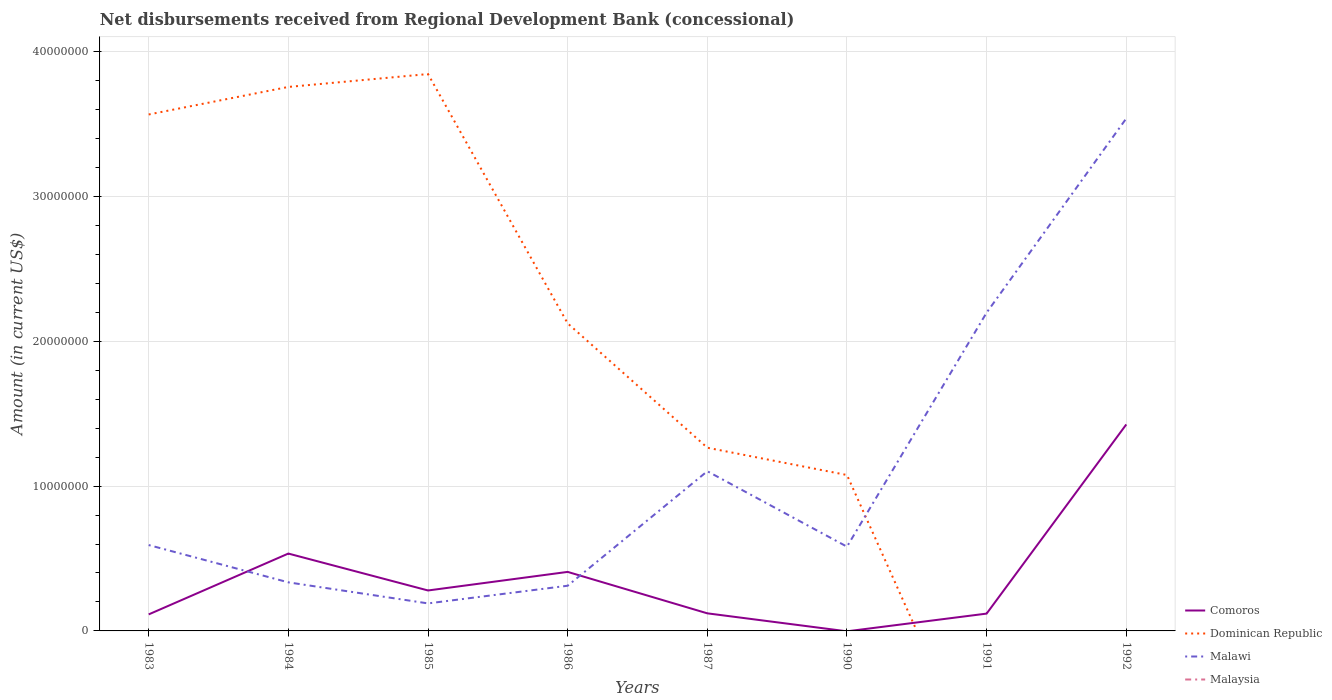How many different coloured lines are there?
Make the answer very short. 3. What is the total amount of disbursements received from Regional Development Bank in Comoros in the graph?
Offer a very short reply. 1.80e+04. What is the difference between the highest and the second highest amount of disbursements received from Regional Development Bank in Comoros?
Your answer should be very brief. 1.43e+07. How many years are there in the graph?
Offer a very short reply. 8. Does the graph contain any zero values?
Your response must be concise. Yes. Where does the legend appear in the graph?
Provide a succinct answer. Bottom right. How many legend labels are there?
Your answer should be compact. 4. What is the title of the graph?
Your answer should be very brief. Net disbursements received from Regional Development Bank (concessional). What is the label or title of the X-axis?
Your answer should be very brief. Years. What is the Amount (in current US$) in Comoros in 1983?
Provide a short and direct response. 1.14e+06. What is the Amount (in current US$) in Dominican Republic in 1983?
Ensure brevity in your answer.  3.57e+07. What is the Amount (in current US$) of Malawi in 1983?
Ensure brevity in your answer.  5.93e+06. What is the Amount (in current US$) of Malaysia in 1983?
Ensure brevity in your answer.  0. What is the Amount (in current US$) in Comoros in 1984?
Your answer should be compact. 5.34e+06. What is the Amount (in current US$) of Dominican Republic in 1984?
Your answer should be compact. 3.76e+07. What is the Amount (in current US$) in Malawi in 1984?
Make the answer very short. 3.35e+06. What is the Amount (in current US$) of Malaysia in 1984?
Offer a terse response. 0. What is the Amount (in current US$) in Comoros in 1985?
Make the answer very short. 2.79e+06. What is the Amount (in current US$) of Dominican Republic in 1985?
Your answer should be compact. 3.85e+07. What is the Amount (in current US$) in Malawi in 1985?
Your response must be concise. 1.90e+06. What is the Amount (in current US$) in Malaysia in 1985?
Ensure brevity in your answer.  0. What is the Amount (in current US$) in Comoros in 1986?
Your answer should be compact. 4.08e+06. What is the Amount (in current US$) in Dominican Republic in 1986?
Your answer should be compact. 2.12e+07. What is the Amount (in current US$) of Malawi in 1986?
Keep it short and to the point. 3.12e+06. What is the Amount (in current US$) in Comoros in 1987?
Keep it short and to the point. 1.21e+06. What is the Amount (in current US$) of Dominican Republic in 1987?
Provide a short and direct response. 1.26e+07. What is the Amount (in current US$) of Malawi in 1987?
Give a very brief answer. 1.10e+07. What is the Amount (in current US$) in Comoros in 1990?
Offer a terse response. 0. What is the Amount (in current US$) in Dominican Republic in 1990?
Keep it short and to the point. 1.08e+07. What is the Amount (in current US$) in Malawi in 1990?
Offer a terse response. 5.82e+06. What is the Amount (in current US$) in Malaysia in 1990?
Provide a short and direct response. 0. What is the Amount (in current US$) in Comoros in 1991?
Offer a very short reply. 1.20e+06. What is the Amount (in current US$) of Malawi in 1991?
Your answer should be compact. 2.20e+07. What is the Amount (in current US$) of Comoros in 1992?
Keep it short and to the point. 1.43e+07. What is the Amount (in current US$) of Dominican Republic in 1992?
Provide a succinct answer. 0. What is the Amount (in current US$) of Malawi in 1992?
Your answer should be very brief. 3.54e+07. Across all years, what is the maximum Amount (in current US$) in Comoros?
Provide a short and direct response. 1.43e+07. Across all years, what is the maximum Amount (in current US$) in Dominican Republic?
Offer a terse response. 3.85e+07. Across all years, what is the maximum Amount (in current US$) of Malawi?
Keep it short and to the point. 3.54e+07. Across all years, what is the minimum Amount (in current US$) of Malawi?
Keep it short and to the point. 1.90e+06. What is the total Amount (in current US$) in Comoros in the graph?
Provide a short and direct response. 3.00e+07. What is the total Amount (in current US$) in Dominican Republic in the graph?
Offer a terse response. 1.56e+08. What is the total Amount (in current US$) of Malawi in the graph?
Offer a very short reply. 8.85e+07. What is the difference between the Amount (in current US$) in Comoros in 1983 and that in 1984?
Your response must be concise. -4.20e+06. What is the difference between the Amount (in current US$) in Dominican Republic in 1983 and that in 1984?
Ensure brevity in your answer.  -1.90e+06. What is the difference between the Amount (in current US$) in Malawi in 1983 and that in 1984?
Make the answer very short. 2.58e+06. What is the difference between the Amount (in current US$) of Comoros in 1983 and that in 1985?
Your response must be concise. -1.65e+06. What is the difference between the Amount (in current US$) in Dominican Republic in 1983 and that in 1985?
Give a very brief answer. -2.79e+06. What is the difference between the Amount (in current US$) of Malawi in 1983 and that in 1985?
Give a very brief answer. 4.03e+06. What is the difference between the Amount (in current US$) of Comoros in 1983 and that in 1986?
Give a very brief answer. -2.94e+06. What is the difference between the Amount (in current US$) of Dominican Republic in 1983 and that in 1986?
Give a very brief answer. 1.44e+07. What is the difference between the Amount (in current US$) in Malawi in 1983 and that in 1986?
Provide a short and direct response. 2.81e+06. What is the difference between the Amount (in current US$) of Comoros in 1983 and that in 1987?
Give a very brief answer. -7.30e+04. What is the difference between the Amount (in current US$) of Dominican Republic in 1983 and that in 1987?
Make the answer very short. 2.30e+07. What is the difference between the Amount (in current US$) of Malawi in 1983 and that in 1987?
Ensure brevity in your answer.  -5.10e+06. What is the difference between the Amount (in current US$) in Dominican Republic in 1983 and that in 1990?
Your response must be concise. 2.49e+07. What is the difference between the Amount (in current US$) in Malawi in 1983 and that in 1990?
Give a very brief answer. 1.12e+05. What is the difference between the Amount (in current US$) in Comoros in 1983 and that in 1991?
Give a very brief answer. -5.50e+04. What is the difference between the Amount (in current US$) of Malawi in 1983 and that in 1991?
Keep it short and to the point. -1.60e+07. What is the difference between the Amount (in current US$) of Comoros in 1983 and that in 1992?
Provide a short and direct response. -1.31e+07. What is the difference between the Amount (in current US$) in Malawi in 1983 and that in 1992?
Offer a terse response. -2.95e+07. What is the difference between the Amount (in current US$) in Comoros in 1984 and that in 1985?
Provide a succinct answer. 2.55e+06. What is the difference between the Amount (in current US$) in Dominican Republic in 1984 and that in 1985?
Offer a very short reply. -8.89e+05. What is the difference between the Amount (in current US$) of Malawi in 1984 and that in 1985?
Offer a terse response. 1.45e+06. What is the difference between the Amount (in current US$) in Comoros in 1984 and that in 1986?
Offer a very short reply. 1.27e+06. What is the difference between the Amount (in current US$) of Dominican Republic in 1984 and that in 1986?
Provide a succinct answer. 1.63e+07. What is the difference between the Amount (in current US$) in Malawi in 1984 and that in 1986?
Your response must be concise. 2.34e+05. What is the difference between the Amount (in current US$) in Comoros in 1984 and that in 1987?
Your answer should be compact. 4.13e+06. What is the difference between the Amount (in current US$) in Dominican Republic in 1984 and that in 1987?
Provide a short and direct response. 2.49e+07. What is the difference between the Amount (in current US$) in Malawi in 1984 and that in 1987?
Your answer should be very brief. -7.67e+06. What is the difference between the Amount (in current US$) in Dominican Republic in 1984 and that in 1990?
Provide a succinct answer. 2.68e+07. What is the difference between the Amount (in current US$) in Malawi in 1984 and that in 1990?
Your response must be concise. -2.46e+06. What is the difference between the Amount (in current US$) in Comoros in 1984 and that in 1991?
Ensure brevity in your answer.  4.15e+06. What is the difference between the Amount (in current US$) of Malawi in 1984 and that in 1991?
Offer a very short reply. -1.86e+07. What is the difference between the Amount (in current US$) in Comoros in 1984 and that in 1992?
Your response must be concise. -8.92e+06. What is the difference between the Amount (in current US$) of Malawi in 1984 and that in 1992?
Offer a terse response. -3.20e+07. What is the difference between the Amount (in current US$) in Comoros in 1985 and that in 1986?
Give a very brief answer. -1.28e+06. What is the difference between the Amount (in current US$) of Dominican Republic in 1985 and that in 1986?
Keep it short and to the point. 1.72e+07. What is the difference between the Amount (in current US$) of Malawi in 1985 and that in 1986?
Offer a very short reply. -1.22e+06. What is the difference between the Amount (in current US$) in Comoros in 1985 and that in 1987?
Offer a very short reply. 1.58e+06. What is the difference between the Amount (in current US$) of Dominican Republic in 1985 and that in 1987?
Keep it short and to the point. 2.58e+07. What is the difference between the Amount (in current US$) in Malawi in 1985 and that in 1987?
Offer a terse response. -9.13e+06. What is the difference between the Amount (in current US$) in Dominican Republic in 1985 and that in 1990?
Ensure brevity in your answer.  2.77e+07. What is the difference between the Amount (in current US$) of Malawi in 1985 and that in 1990?
Your answer should be compact. -3.92e+06. What is the difference between the Amount (in current US$) of Comoros in 1985 and that in 1991?
Ensure brevity in your answer.  1.60e+06. What is the difference between the Amount (in current US$) of Malawi in 1985 and that in 1991?
Ensure brevity in your answer.  -2.01e+07. What is the difference between the Amount (in current US$) of Comoros in 1985 and that in 1992?
Your response must be concise. -1.15e+07. What is the difference between the Amount (in current US$) in Malawi in 1985 and that in 1992?
Provide a short and direct response. -3.35e+07. What is the difference between the Amount (in current US$) in Comoros in 1986 and that in 1987?
Ensure brevity in your answer.  2.86e+06. What is the difference between the Amount (in current US$) of Dominican Republic in 1986 and that in 1987?
Your response must be concise. 8.59e+06. What is the difference between the Amount (in current US$) of Malawi in 1986 and that in 1987?
Give a very brief answer. -7.91e+06. What is the difference between the Amount (in current US$) of Dominican Republic in 1986 and that in 1990?
Make the answer very short. 1.05e+07. What is the difference between the Amount (in current US$) in Malawi in 1986 and that in 1990?
Your response must be concise. -2.70e+06. What is the difference between the Amount (in current US$) in Comoros in 1986 and that in 1991?
Provide a short and direct response. 2.88e+06. What is the difference between the Amount (in current US$) of Malawi in 1986 and that in 1991?
Offer a very short reply. -1.89e+07. What is the difference between the Amount (in current US$) in Comoros in 1986 and that in 1992?
Give a very brief answer. -1.02e+07. What is the difference between the Amount (in current US$) of Malawi in 1986 and that in 1992?
Offer a very short reply. -3.23e+07. What is the difference between the Amount (in current US$) of Dominican Republic in 1987 and that in 1990?
Offer a very short reply. 1.88e+06. What is the difference between the Amount (in current US$) of Malawi in 1987 and that in 1990?
Provide a short and direct response. 5.21e+06. What is the difference between the Amount (in current US$) of Comoros in 1987 and that in 1991?
Offer a terse response. 1.80e+04. What is the difference between the Amount (in current US$) in Malawi in 1987 and that in 1991?
Offer a very short reply. -1.10e+07. What is the difference between the Amount (in current US$) of Comoros in 1987 and that in 1992?
Your answer should be compact. -1.30e+07. What is the difference between the Amount (in current US$) in Malawi in 1987 and that in 1992?
Ensure brevity in your answer.  -2.44e+07. What is the difference between the Amount (in current US$) in Malawi in 1990 and that in 1991?
Keep it short and to the point. -1.62e+07. What is the difference between the Amount (in current US$) of Malawi in 1990 and that in 1992?
Your response must be concise. -2.96e+07. What is the difference between the Amount (in current US$) of Comoros in 1991 and that in 1992?
Keep it short and to the point. -1.31e+07. What is the difference between the Amount (in current US$) of Malawi in 1991 and that in 1992?
Ensure brevity in your answer.  -1.34e+07. What is the difference between the Amount (in current US$) in Comoros in 1983 and the Amount (in current US$) in Dominican Republic in 1984?
Your answer should be compact. -3.64e+07. What is the difference between the Amount (in current US$) of Comoros in 1983 and the Amount (in current US$) of Malawi in 1984?
Provide a succinct answer. -2.21e+06. What is the difference between the Amount (in current US$) in Dominican Republic in 1983 and the Amount (in current US$) in Malawi in 1984?
Ensure brevity in your answer.  3.23e+07. What is the difference between the Amount (in current US$) in Comoros in 1983 and the Amount (in current US$) in Dominican Republic in 1985?
Provide a short and direct response. -3.73e+07. What is the difference between the Amount (in current US$) in Comoros in 1983 and the Amount (in current US$) in Malawi in 1985?
Offer a terse response. -7.59e+05. What is the difference between the Amount (in current US$) of Dominican Republic in 1983 and the Amount (in current US$) of Malawi in 1985?
Your answer should be very brief. 3.38e+07. What is the difference between the Amount (in current US$) of Comoros in 1983 and the Amount (in current US$) of Dominican Republic in 1986?
Your answer should be very brief. -2.01e+07. What is the difference between the Amount (in current US$) of Comoros in 1983 and the Amount (in current US$) of Malawi in 1986?
Your answer should be very brief. -1.98e+06. What is the difference between the Amount (in current US$) in Dominican Republic in 1983 and the Amount (in current US$) in Malawi in 1986?
Your response must be concise. 3.25e+07. What is the difference between the Amount (in current US$) in Comoros in 1983 and the Amount (in current US$) in Dominican Republic in 1987?
Offer a terse response. -1.15e+07. What is the difference between the Amount (in current US$) of Comoros in 1983 and the Amount (in current US$) of Malawi in 1987?
Your answer should be very brief. -9.89e+06. What is the difference between the Amount (in current US$) of Dominican Republic in 1983 and the Amount (in current US$) of Malawi in 1987?
Make the answer very short. 2.46e+07. What is the difference between the Amount (in current US$) of Comoros in 1983 and the Amount (in current US$) of Dominican Republic in 1990?
Keep it short and to the point. -9.62e+06. What is the difference between the Amount (in current US$) in Comoros in 1983 and the Amount (in current US$) in Malawi in 1990?
Offer a terse response. -4.68e+06. What is the difference between the Amount (in current US$) of Dominican Republic in 1983 and the Amount (in current US$) of Malawi in 1990?
Keep it short and to the point. 2.98e+07. What is the difference between the Amount (in current US$) in Comoros in 1983 and the Amount (in current US$) in Malawi in 1991?
Your answer should be compact. -2.08e+07. What is the difference between the Amount (in current US$) of Dominican Republic in 1983 and the Amount (in current US$) of Malawi in 1991?
Give a very brief answer. 1.37e+07. What is the difference between the Amount (in current US$) of Comoros in 1983 and the Amount (in current US$) of Malawi in 1992?
Make the answer very short. -3.42e+07. What is the difference between the Amount (in current US$) in Dominican Republic in 1983 and the Amount (in current US$) in Malawi in 1992?
Offer a terse response. 2.71e+05. What is the difference between the Amount (in current US$) in Comoros in 1984 and the Amount (in current US$) in Dominican Republic in 1985?
Your answer should be very brief. -3.31e+07. What is the difference between the Amount (in current US$) in Comoros in 1984 and the Amount (in current US$) in Malawi in 1985?
Keep it short and to the point. 3.44e+06. What is the difference between the Amount (in current US$) in Dominican Republic in 1984 and the Amount (in current US$) in Malawi in 1985?
Offer a very short reply. 3.57e+07. What is the difference between the Amount (in current US$) in Comoros in 1984 and the Amount (in current US$) in Dominican Republic in 1986?
Offer a very short reply. -1.59e+07. What is the difference between the Amount (in current US$) in Comoros in 1984 and the Amount (in current US$) in Malawi in 1986?
Your response must be concise. 2.22e+06. What is the difference between the Amount (in current US$) in Dominican Republic in 1984 and the Amount (in current US$) in Malawi in 1986?
Ensure brevity in your answer.  3.44e+07. What is the difference between the Amount (in current US$) of Comoros in 1984 and the Amount (in current US$) of Dominican Republic in 1987?
Ensure brevity in your answer.  -7.31e+06. What is the difference between the Amount (in current US$) of Comoros in 1984 and the Amount (in current US$) of Malawi in 1987?
Provide a succinct answer. -5.68e+06. What is the difference between the Amount (in current US$) of Dominican Republic in 1984 and the Amount (in current US$) of Malawi in 1987?
Give a very brief answer. 2.65e+07. What is the difference between the Amount (in current US$) in Comoros in 1984 and the Amount (in current US$) in Dominican Republic in 1990?
Give a very brief answer. -5.42e+06. What is the difference between the Amount (in current US$) of Comoros in 1984 and the Amount (in current US$) of Malawi in 1990?
Your response must be concise. -4.76e+05. What is the difference between the Amount (in current US$) of Dominican Republic in 1984 and the Amount (in current US$) of Malawi in 1990?
Ensure brevity in your answer.  3.17e+07. What is the difference between the Amount (in current US$) in Comoros in 1984 and the Amount (in current US$) in Malawi in 1991?
Make the answer very short. -1.66e+07. What is the difference between the Amount (in current US$) in Dominican Republic in 1984 and the Amount (in current US$) in Malawi in 1991?
Give a very brief answer. 1.56e+07. What is the difference between the Amount (in current US$) of Comoros in 1984 and the Amount (in current US$) of Malawi in 1992?
Give a very brief answer. -3.00e+07. What is the difference between the Amount (in current US$) of Dominican Republic in 1984 and the Amount (in current US$) of Malawi in 1992?
Make the answer very short. 2.17e+06. What is the difference between the Amount (in current US$) in Comoros in 1985 and the Amount (in current US$) in Dominican Republic in 1986?
Provide a succinct answer. -1.84e+07. What is the difference between the Amount (in current US$) in Comoros in 1985 and the Amount (in current US$) in Malawi in 1986?
Offer a terse response. -3.27e+05. What is the difference between the Amount (in current US$) in Dominican Republic in 1985 and the Amount (in current US$) in Malawi in 1986?
Provide a succinct answer. 3.53e+07. What is the difference between the Amount (in current US$) in Comoros in 1985 and the Amount (in current US$) in Dominican Republic in 1987?
Offer a terse response. -9.86e+06. What is the difference between the Amount (in current US$) of Comoros in 1985 and the Amount (in current US$) of Malawi in 1987?
Provide a succinct answer. -8.23e+06. What is the difference between the Amount (in current US$) in Dominican Republic in 1985 and the Amount (in current US$) in Malawi in 1987?
Make the answer very short. 2.74e+07. What is the difference between the Amount (in current US$) in Comoros in 1985 and the Amount (in current US$) in Dominican Republic in 1990?
Offer a terse response. -7.97e+06. What is the difference between the Amount (in current US$) of Comoros in 1985 and the Amount (in current US$) of Malawi in 1990?
Provide a succinct answer. -3.02e+06. What is the difference between the Amount (in current US$) in Dominican Republic in 1985 and the Amount (in current US$) in Malawi in 1990?
Make the answer very short. 3.26e+07. What is the difference between the Amount (in current US$) of Comoros in 1985 and the Amount (in current US$) of Malawi in 1991?
Offer a terse response. -1.92e+07. What is the difference between the Amount (in current US$) in Dominican Republic in 1985 and the Amount (in current US$) in Malawi in 1991?
Your answer should be compact. 1.65e+07. What is the difference between the Amount (in current US$) in Comoros in 1985 and the Amount (in current US$) in Malawi in 1992?
Offer a very short reply. -3.26e+07. What is the difference between the Amount (in current US$) in Dominican Republic in 1985 and the Amount (in current US$) in Malawi in 1992?
Offer a very short reply. 3.06e+06. What is the difference between the Amount (in current US$) in Comoros in 1986 and the Amount (in current US$) in Dominican Republic in 1987?
Your answer should be very brief. -8.57e+06. What is the difference between the Amount (in current US$) in Comoros in 1986 and the Amount (in current US$) in Malawi in 1987?
Provide a short and direct response. -6.95e+06. What is the difference between the Amount (in current US$) of Dominican Republic in 1986 and the Amount (in current US$) of Malawi in 1987?
Your response must be concise. 1.02e+07. What is the difference between the Amount (in current US$) in Comoros in 1986 and the Amount (in current US$) in Dominican Republic in 1990?
Offer a very short reply. -6.69e+06. What is the difference between the Amount (in current US$) of Comoros in 1986 and the Amount (in current US$) of Malawi in 1990?
Your response must be concise. -1.74e+06. What is the difference between the Amount (in current US$) in Dominican Republic in 1986 and the Amount (in current US$) in Malawi in 1990?
Give a very brief answer. 1.54e+07. What is the difference between the Amount (in current US$) of Comoros in 1986 and the Amount (in current US$) of Malawi in 1991?
Provide a short and direct response. -1.79e+07. What is the difference between the Amount (in current US$) of Dominican Republic in 1986 and the Amount (in current US$) of Malawi in 1991?
Provide a short and direct response. -7.41e+05. What is the difference between the Amount (in current US$) in Comoros in 1986 and the Amount (in current US$) in Malawi in 1992?
Provide a short and direct response. -3.13e+07. What is the difference between the Amount (in current US$) in Dominican Republic in 1986 and the Amount (in current US$) in Malawi in 1992?
Your response must be concise. -1.42e+07. What is the difference between the Amount (in current US$) of Comoros in 1987 and the Amount (in current US$) of Dominican Republic in 1990?
Offer a very short reply. -9.55e+06. What is the difference between the Amount (in current US$) in Comoros in 1987 and the Amount (in current US$) in Malawi in 1990?
Make the answer very short. -4.60e+06. What is the difference between the Amount (in current US$) of Dominican Republic in 1987 and the Amount (in current US$) of Malawi in 1990?
Your response must be concise. 6.83e+06. What is the difference between the Amount (in current US$) in Comoros in 1987 and the Amount (in current US$) in Malawi in 1991?
Offer a terse response. -2.08e+07. What is the difference between the Amount (in current US$) in Dominican Republic in 1987 and the Amount (in current US$) in Malawi in 1991?
Offer a very short reply. -9.33e+06. What is the difference between the Amount (in current US$) in Comoros in 1987 and the Amount (in current US$) in Malawi in 1992?
Provide a short and direct response. -3.42e+07. What is the difference between the Amount (in current US$) in Dominican Republic in 1987 and the Amount (in current US$) in Malawi in 1992?
Make the answer very short. -2.27e+07. What is the difference between the Amount (in current US$) in Dominican Republic in 1990 and the Amount (in current US$) in Malawi in 1991?
Offer a very short reply. -1.12e+07. What is the difference between the Amount (in current US$) in Dominican Republic in 1990 and the Amount (in current US$) in Malawi in 1992?
Offer a terse response. -2.46e+07. What is the difference between the Amount (in current US$) in Comoros in 1991 and the Amount (in current US$) in Malawi in 1992?
Give a very brief answer. -3.42e+07. What is the average Amount (in current US$) in Comoros per year?
Ensure brevity in your answer.  3.75e+06. What is the average Amount (in current US$) in Dominican Republic per year?
Your answer should be very brief. 1.95e+07. What is the average Amount (in current US$) of Malawi per year?
Your response must be concise. 1.11e+07. What is the average Amount (in current US$) in Malaysia per year?
Provide a short and direct response. 0. In the year 1983, what is the difference between the Amount (in current US$) of Comoros and Amount (in current US$) of Dominican Republic?
Offer a very short reply. -3.45e+07. In the year 1983, what is the difference between the Amount (in current US$) of Comoros and Amount (in current US$) of Malawi?
Ensure brevity in your answer.  -4.79e+06. In the year 1983, what is the difference between the Amount (in current US$) in Dominican Republic and Amount (in current US$) in Malawi?
Ensure brevity in your answer.  2.97e+07. In the year 1984, what is the difference between the Amount (in current US$) in Comoros and Amount (in current US$) in Dominican Republic?
Give a very brief answer. -3.22e+07. In the year 1984, what is the difference between the Amount (in current US$) of Comoros and Amount (in current US$) of Malawi?
Keep it short and to the point. 1.99e+06. In the year 1984, what is the difference between the Amount (in current US$) of Dominican Republic and Amount (in current US$) of Malawi?
Offer a very short reply. 3.42e+07. In the year 1985, what is the difference between the Amount (in current US$) of Comoros and Amount (in current US$) of Dominican Republic?
Provide a succinct answer. -3.57e+07. In the year 1985, what is the difference between the Amount (in current US$) of Comoros and Amount (in current US$) of Malawi?
Provide a short and direct response. 8.93e+05. In the year 1985, what is the difference between the Amount (in current US$) in Dominican Republic and Amount (in current US$) in Malawi?
Offer a very short reply. 3.66e+07. In the year 1986, what is the difference between the Amount (in current US$) of Comoros and Amount (in current US$) of Dominican Republic?
Offer a very short reply. -1.72e+07. In the year 1986, what is the difference between the Amount (in current US$) in Comoros and Amount (in current US$) in Malawi?
Ensure brevity in your answer.  9.56e+05. In the year 1986, what is the difference between the Amount (in current US$) of Dominican Republic and Amount (in current US$) of Malawi?
Offer a very short reply. 1.81e+07. In the year 1987, what is the difference between the Amount (in current US$) of Comoros and Amount (in current US$) of Dominican Republic?
Keep it short and to the point. -1.14e+07. In the year 1987, what is the difference between the Amount (in current US$) in Comoros and Amount (in current US$) in Malawi?
Your response must be concise. -9.81e+06. In the year 1987, what is the difference between the Amount (in current US$) in Dominican Republic and Amount (in current US$) in Malawi?
Your answer should be very brief. 1.62e+06. In the year 1990, what is the difference between the Amount (in current US$) of Dominican Republic and Amount (in current US$) of Malawi?
Keep it short and to the point. 4.95e+06. In the year 1991, what is the difference between the Amount (in current US$) of Comoros and Amount (in current US$) of Malawi?
Give a very brief answer. -2.08e+07. In the year 1992, what is the difference between the Amount (in current US$) of Comoros and Amount (in current US$) of Malawi?
Your answer should be very brief. -2.11e+07. What is the ratio of the Amount (in current US$) in Comoros in 1983 to that in 1984?
Give a very brief answer. 0.21. What is the ratio of the Amount (in current US$) of Dominican Republic in 1983 to that in 1984?
Offer a very short reply. 0.95. What is the ratio of the Amount (in current US$) in Malawi in 1983 to that in 1984?
Your answer should be very brief. 1.77. What is the ratio of the Amount (in current US$) of Comoros in 1983 to that in 1985?
Offer a very short reply. 0.41. What is the ratio of the Amount (in current US$) of Dominican Republic in 1983 to that in 1985?
Make the answer very short. 0.93. What is the ratio of the Amount (in current US$) of Malawi in 1983 to that in 1985?
Make the answer very short. 3.12. What is the ratio of the Amount (in current US$) of Comoros in 1983 to that in 1986?
Keep it short and to the point. 0.28. What is the ratio of the Amount (in current US$) in Dominican Republic in 1983 to that in 1986?
Keep it short and to the point. 1.68. What is the ratio of the Amount (in current US$) in Malawi in 1983 to that in 1986?
Provide a short and direct response. 1.9. What is the ratio of the Amount (in current US$) of Comoros in 1983 to that in 1987?
Your answer should be very brief. 0.94. What is the ratio of the Amount (in current US$) in Dominican Republic in 1983 to that in 1987?
Offer a very short reply. 2.82. What is the ratio of the Amount (in current US$) in Malawi in 1983 to that in 1987?
Make the answer very short. 0.54. What is the ratio of the Amount (in current US$) in Dominican Republic in 1983 to that in 1990?
Your response must be concise. 3.31. What is the ratio of the Amount (in current US$) of Malawi in 1983 to that in 1990?
Ensure brevity in your answer.  1.02. What is the ratio of the Amount (in current US$) of Comoros in 1983 to that in 1991?
Keep it short and to the point. 0.95. What is the ratio of the Amount (in current US$) in Malawi in 1983 to that in 1991?
Your response must be concise. 0.27. What is the ratio of the Amount (in current US$) in Comoros in 1983 to that in 1992?
Ensure brevity in your answer.  0.08. What is the ratio of the Amount (in current US$) of Malawi in 1983 to that in 1992?
Your answer should be very brief. 0.17. What is the ratio of the Amount (in current US$) in Comoros in 1984 to that in 1985?
Offer a terse response. 1.91. What is the ratio of the Amount (in current US$) in Dominican Republic in 1984 to that in 1985?
Ensure brevity in your answer.  0.98. What is the ratio of the Amount (in current US$) of Malawi in 1984 to that in 1985?
Offer a very short reply. 1.77. What is the ratio of the Amount (in current US$) of Comoros in 1984 to that in 1986?
Your response must be concise. 1.31. What is the ratio of the Amount (in current US$) of Dominican Republic in 1984 to that in 1986?
Provide a succinct answer. 1.77. What is the ratio of the Amount (in current US$) of Malawi in 1984 to that in 1986?
Your response must be concise. 1.07. What is the ratio of the Amount (in current US$) in Comoros in 1984 to that in 1987?
Offer a very short reply. 4.4. What is the ratio of the Amount (in current US$) in Dominican Republic in 1984 to that in 1987?
Make the answer very short. 2.97. What is the ratio of the Amount (in current US$) of Malawi in 1984 to that in 1987?
Your answer should be compact. 0.3. What is the ratio of the Amount (in current US$) of Dominican Republic in 1984 to that in 1990?
Ensure brevity in your answer.  3.49. What is the ratio of the Amount (in current US$) in Malawi in 1984 to that in 1990?
Offer a terse response. 0.58. What is the ratio of the Amount (in current US$) in Comoros in 1984 to that in 1991?
Your response must be concise. 4.47. What is the ratio of the Amount (in current US$) in Malawi in 1984 to that in 1991?
Make the answer very short. 0.15. What is the ratio of the Amount (in current US$) in Comoros in 1984 to that in 1992?
Make the answer very short. 0.37. What is the ratio of the Amount (in current US$) in Malawi in 1984 to that in 1992?
Provide a succinct answer. 0.09. What is the ratio of the Amount (in current US$) of Comoros in 1985 to that in 1986?
Your answer should be compact. 0.69. What is the ratio of the Amount (in current US$) of Dominican Republic in 1985 to that in 1986?
Your response must be concise. 1.81. What is the ratio of the Amount (in current US$) of Malawi in 1985 to that in 1986?
Offer a terse response. 0.61. What is the ratio of the Amount (in current US$) in Comoros in 1985 to that in 1987?
Your response must be concise. 2.3. What is the ratio of the Amount (in current US$) of Dominican Republic in 1985 to that in 1987?
Keep it short and to the point. 3.04. What is the ratio of the Amount (in current US$) in Malawi in 1985 to that in 1987?
Keep it short and to the point. 0.17. What is the ratio of the Amount (in current US$) of Dominican Republic in 1985 to that in 1990?
Give a very brief answer. 3.57. What is the ratio of the Amount (in current US$) of Malawi in 1985 to that in 1990?
Keep it short and to the point. 0.33. What is the ratio of the Amount (in current US$) in Comoros in 1985 to that in 1991?
Make the answer very short. 2.34. What is the ratio of the Amount (in current US$) of Malawi in 1985 to that in 1991?
Give a very brief answer. 0.09. What is the ratio of the Amount (in current US$) in Comoros in 1985 to that in 1992?
Offer a terse response. 0.2. What is the ratio of the Amount (in current US$) in Malawi in 1985 to that in 1992?
Make the answer very short. 0.05. What is the ratio of the Amount (in current US$) in Comoros in 1986 to that in 1987?
Give a very brief answer. 3.36. What is the ratio of the Amount (in current US$) of Dominican Republic in 1986 to that in 1987?
Keep it short and to the point. 1.68. What is the ratio of the Amount (in current US$) in Malawi in 1986 to that in 1987?
Give a very brief answer. 0.28. What is the ratio of the Amount (in current US$) in Dominican Republic in 1986 to that in 1990?
Offer a terse response. 1.97. What is the ratio of the Amount (in current US$) of Malawi in 1986 to that in 1990?
Ensure brevity in your answer.  0.54. What is the ratio of the Amount (in current US$) of Comoros in 1986 to that in 1991?
Offer a terse response. 3.41. What is the ratio of the Amount (in current US$) of Malawi in 1986 to that in 1991?
Your answer should be very brief. 0.14. What is the ratio of the Amount (in current US$) in Comoros in 1986 to that in 1992?
Offer a very short reply. 0.29. What is the ratio of the Amount (in current US$) in Malawi in 1986 to that in 1992?
Offer a very short reply. 0.09. What is the ratio of the Amount (in current US$) in Dominican Republic in 1987 to that in 1990?
Ensure brevity in your answer.  1.18. What is the ratio of the Amount (in current US$) of Malawi in 1987 to that in 1990?
Ensure brevity in your answer.  1.9. What is the ratio of the Amount (in current US$) in Comoros in 1987 to that in 1991?
Offer a very short reply. 1.02. What is the ratio of the Amount (in current US$) of Malawi in 1987 to that in 1991?
Your answer should be very brief. 0.5. What is the ratio of the Amount (in current US$) in Comoros in 1987 to that in 1992?
Ensure brevity in your answer.  0.09. What is the ratio of the Amount (in current US$) of Malawi in 1987 to that in 1992?
Ensure brevity in your answer.  0.31. What is the ratio of the Amount (in current US$) of Malawi in 1990 to that in 1991?
Make the answer very short. 0.26. What is the ratio of the Amount (in current US$) of Malawi in 1990 to that in 1992?
Offer a terse response. 0.16. What is the ratio of the Amount (in current US$) of Comoros in 1991 to that in 1992?
Keep it short and to the point. 0.08. What is the ratio of the Amount (in current US$) in Malawi in 1991 to that in 1992?
Your answer should be compact. 0.62. What is the difference between the highest and the second highest Amount (in current US$) of Comoros?
Provide a succinct answer. 8.92e+06. What is the difference between the highest and the second highest Amount (in current US$) of Dominican Republic?
Your answer should be compact. 8.89e+05. What is the difference between the highest and the second highest Amount (in current US$) in Malawi?
Keep it short and to the point. 1.34e+07. What is the difference between the highest and the lowest Amount (in current US$) of Comoros?
Your response must be concise. 1.43e+07. What is the difference between the highest and the lowest Amount (in current US$) in Dominican Republic?
Offer a terse response. 3.85e+07. What is the difference between the highest and the lowest Amount (in current US$) of Malawi?
Provide a succinct answer. 3.35e+07. 